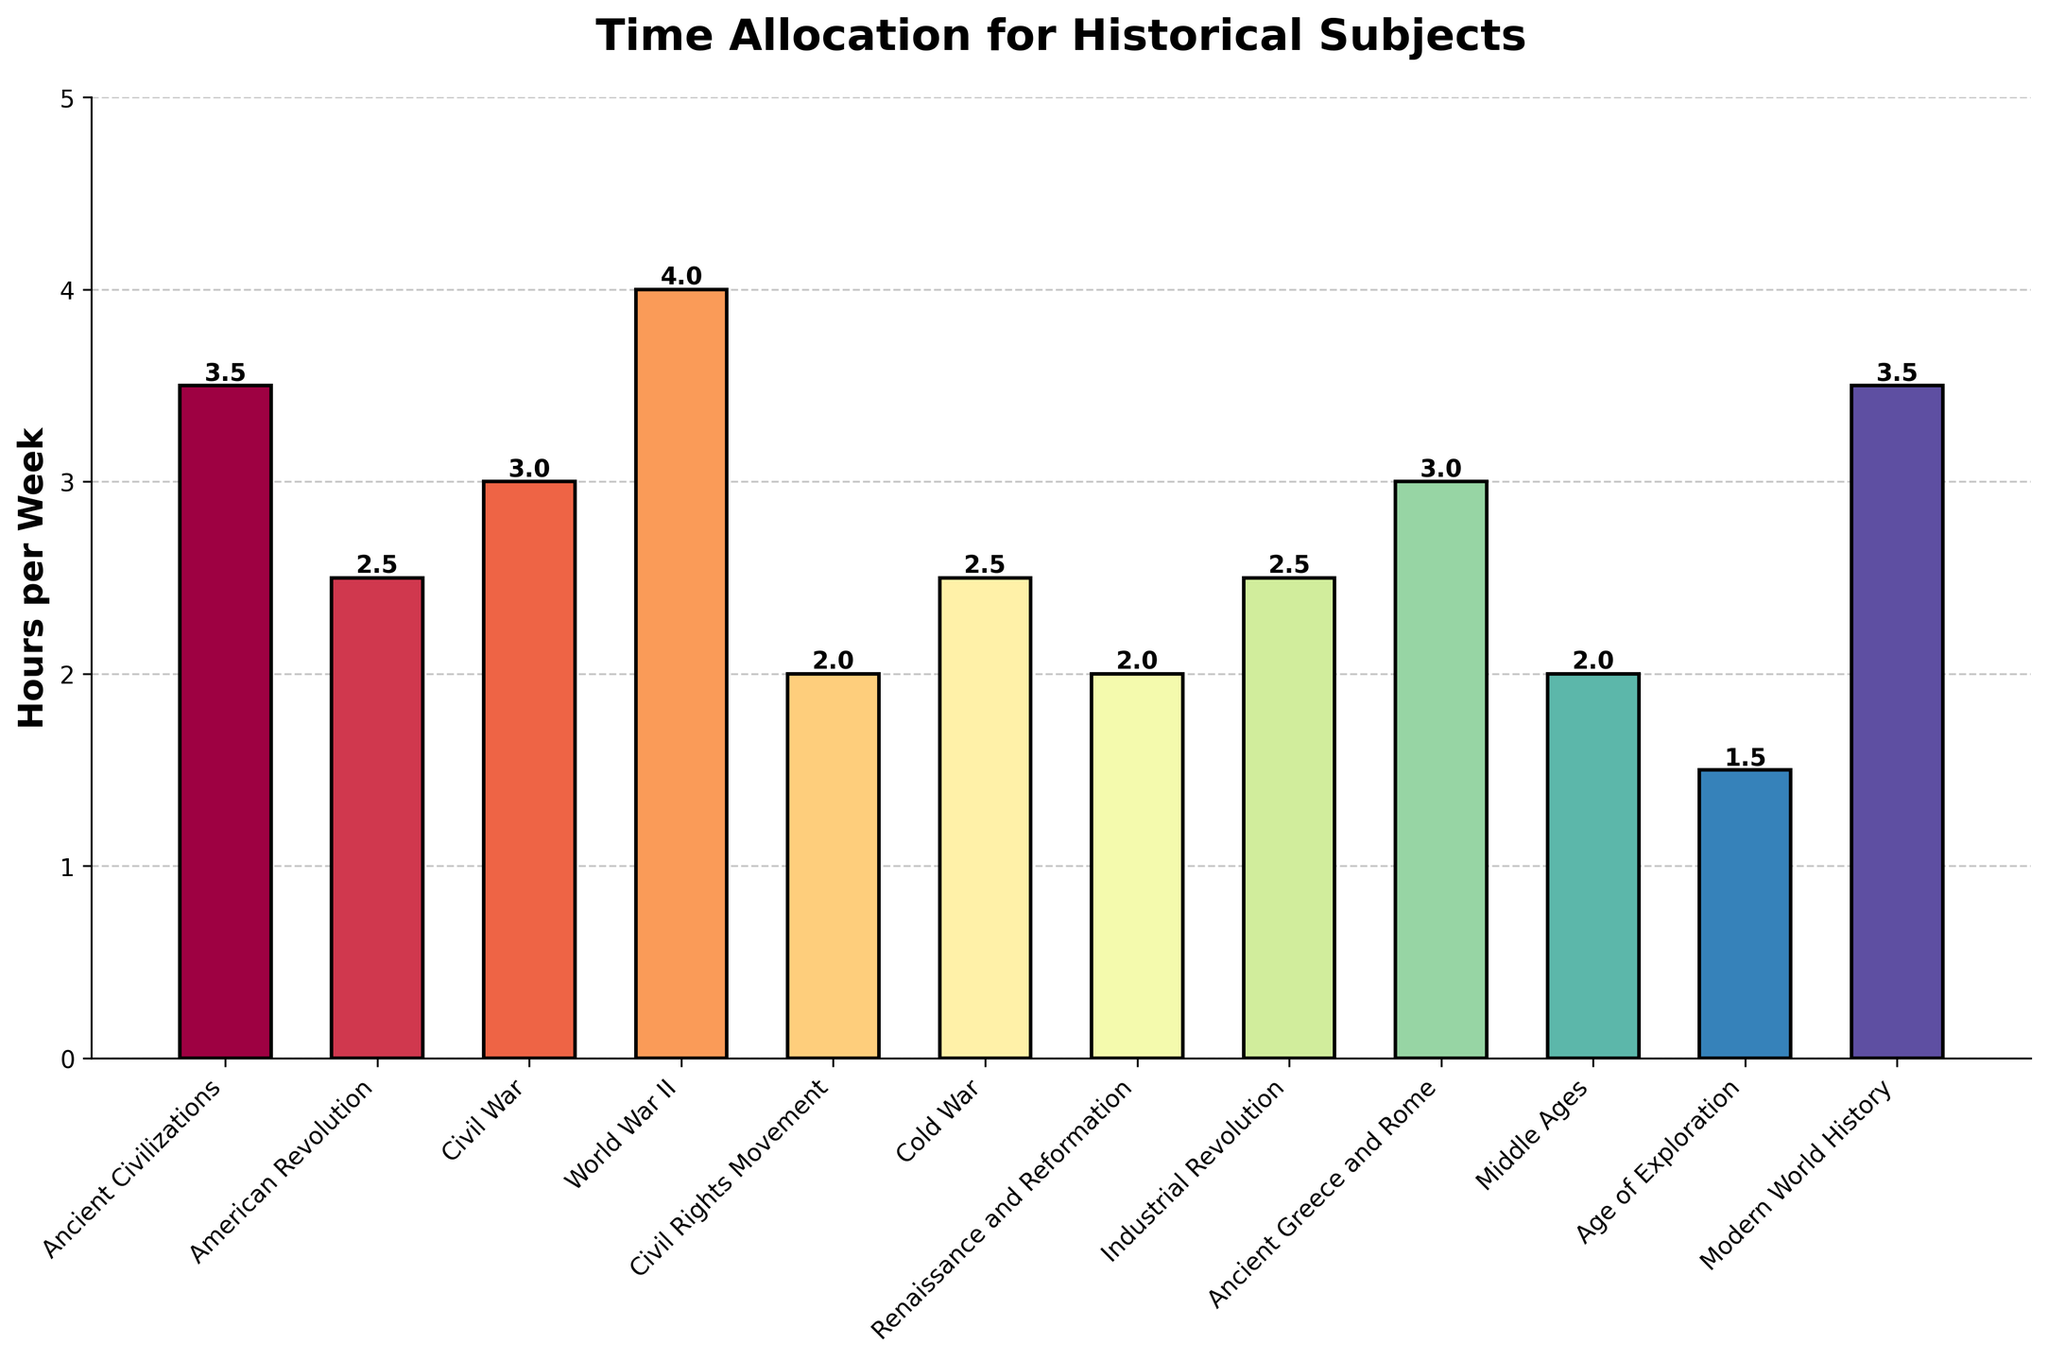Which historical subject has the highest weekly time allocation? The bar representing "World War II" is the tallest among all the bars, indicating it has the highest time allocation.
Answer: World War II What is the combined weekly time allocation for the American Revolution and the Cold War? The bar for "American Revolution" represents 2.5 hours and the bar for "Cold War" represents 2.5 hours. Summing these gives 2.5 + 2.5 = 5 hours.
Answer: 5 hours How much more weekly time is allocated to Ancient Civilizations compared to the Civil Rights Movement? The bar for "Ancient Civilizations" is at 3.5 hours and the bar for "Civil Rights Movement" is at 2 hours. The difference is 3.5 - 2 = 1.5 hours.
Answer: 1.5 hours Which subjects have the same weekly time allocation? The bars for "American Revolution," "Cold War," and "Industrial Revolution" are at the same height of 2.5 hours per week.
Answer: American Revolution, Cold War, Industrial Revolution What is the average weekly time allocation for Ancient Civilizations, World War II, and Modern World History? The bars represent 3.5 hours for Ancient Civilizations, 4 hours for World War II, and 3.5 hours for Modern World History. The sum is 3.5 + 4 + 3.5 = 11 hours. The average is 11 / 3 ≈ 3.67 hours.
Answer: ≈ 3.67 hours What’s the total weekly time allocation for all historical subjects combined? Summing the hours: 3.5 + 2.5 + 3 + 4 + 2 + 2.5 + 2 + 2.5 + 3 + 2 + 1.5 + 3.5 = 32.5 hours.
Answer: 32.5 hours Which subject has the least weekly time allocation, and what is it? The shortest bar represents "Age of Exploration," with a time allocation of 1.5 hours.
Answer: Age of Exploration, 1.5 hours Are there more subjects with a weekly time allocation of 3 hours or more, or less than 3 hours? Subjects with 3 hours or more: Ancient Civilizations, Civil War, World War II, Ancient Greece and Rome, Modern World History (5 subjects). Subjects with less than 3 hours: American Revolution, Civil Rights Movement, Cold War, Renaissance and Reformation, Industrial Revolution, Middle Ages, Age of Exploration (7 subjects). There are more subjects with less than 3 hours.
Answer: Less than 3 hours By how much does the time allocated to the Modern World History exceed the time allocated to the Industrial Revolution? The bar for "Modern World History" represents 3.5 hours and the bar for "Industrial Revolution" is at 2.5 hours. The difference is 3.5 - 2.5 = 1 hour.
Answer: 1 hour 